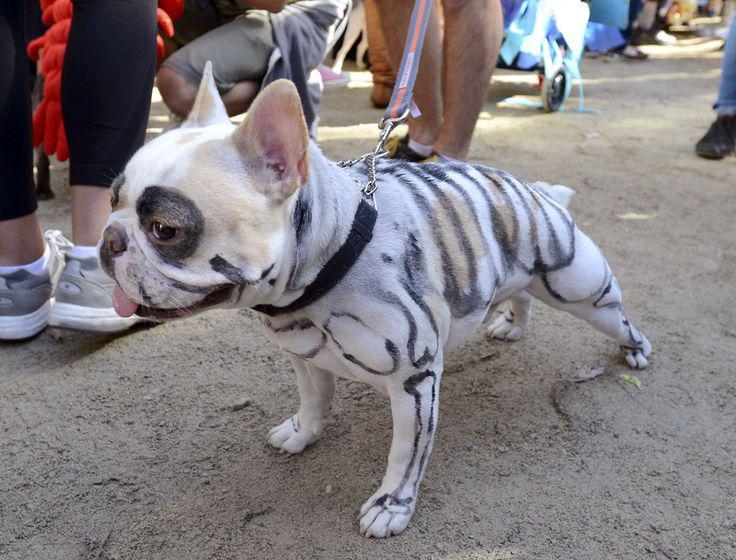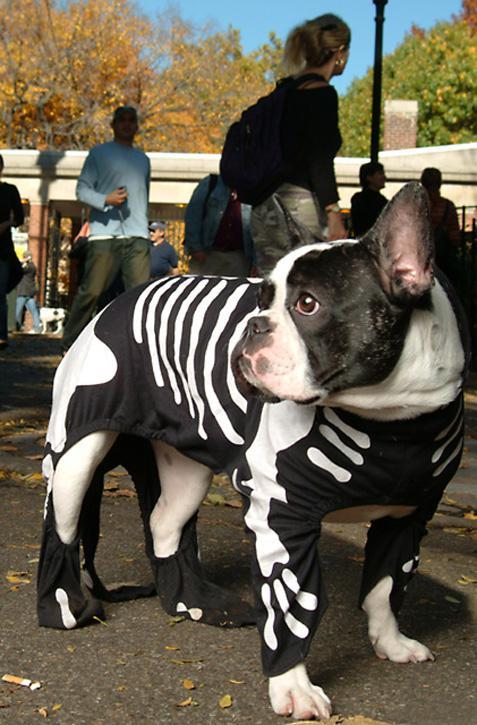The first image is the image on the left, the second image is the image on the right. Evaluate the accuracy of this statement regarding the images: "There is one dog touching another dog with their face in one of the images.". Is it true? Answer yes or no. No. The first image is the image on the left, the second image is the image on the right. Assess this claim about the two images: "One image shows a beige pug in a white 'sheet' leaning its face into a black pug wearing a skeleton costume.". Correct or not? Answer yes or no. No. 